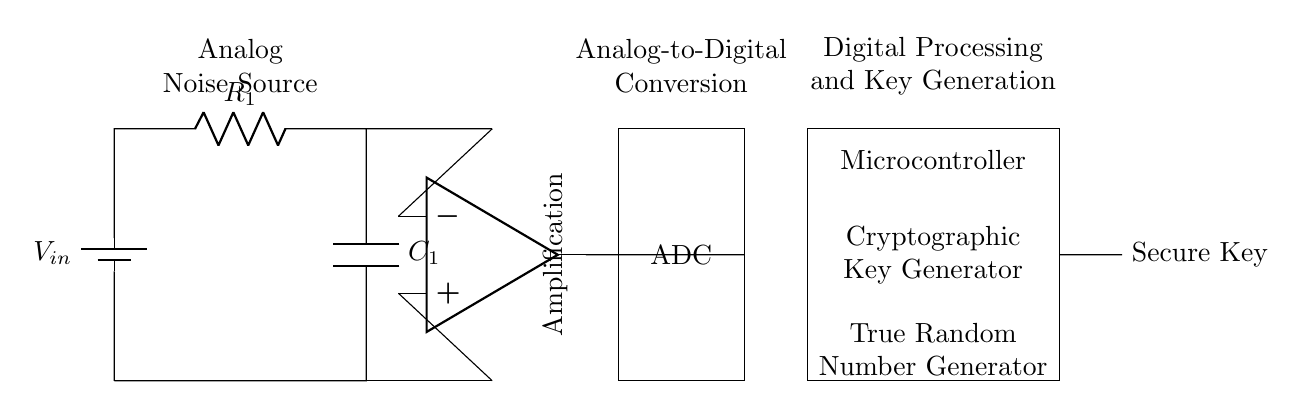What type of noise source is represented? The circuit shows an "Analog Noise Source," which often generates unpredictable voltage variations used for key generation.
Answer: Analog Noise Source What component is used for amplification? The component labeled as "Op-amp" is used for signal amplification in the circuit.
Answer: Op-amp How many main sections are in this circuit? There are three main sections: the analog section, the analog-to-digital converter section, and the digital processing section.
Answer: Three What is the role of the ADC in this circuit? The ADC (Analog-to-Digital Converter) converts the amplified analog signal into a digital signal for further processing.
Answer: Digital signal conversion Which component generates the secure key? The "Microcontroller" section contains the "Cryptographic Key Generator" that produces the secure key.
Answer: Microcontroller What is the purpose of the capacitor in this circuit? The capacitor, labeled as C1, is used to filter the signal, potentially stabilizing it against noise for better key generation.
Answer: Filtering signal What can be inferred about the type of key generation being used? The circuit utilizes a True Random Number Generator, implying that the key generation relies on random fluctuations for security.
Answer: True Random Number Generator 